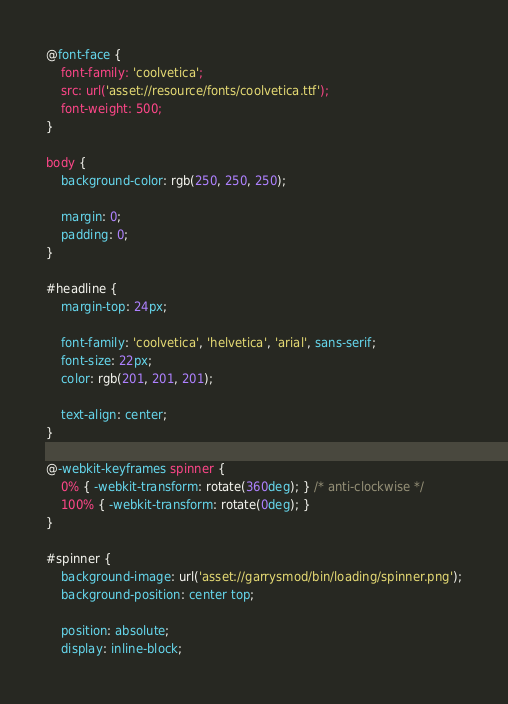<code> <loc_0><loc_0><loc_500><loc_500><_CSS_>@font-face {
	font-family: 'coolvetica';
	src: url('asset://resource/fonts/coolvetica.ttf');
	font-weight: 500;
}

body {
	background-color: rgb(250, 250, 250);

	margin: 0;
	padding: 0;
}

#headline {
	margin-top: 24px;

	font-family: 'coolvetica', 'helvetica', 'arial', sans-serif;
	font-size: 22px;
	color: rgb(201, 201, 201);

	text-align: center;
}

@-webkit-keyframes spinner {
	0% { -webkit-transform: rotate(360deg); } /* anti-clockwise */
	100% { -webkit-transform: rotate(0deg); }
}

#spinner {
	background-image: url('asset://garrysmod/bin/loading/spinner.png');
	background-position: center top;

	position: absolute;
	display: inline-block;</code> 